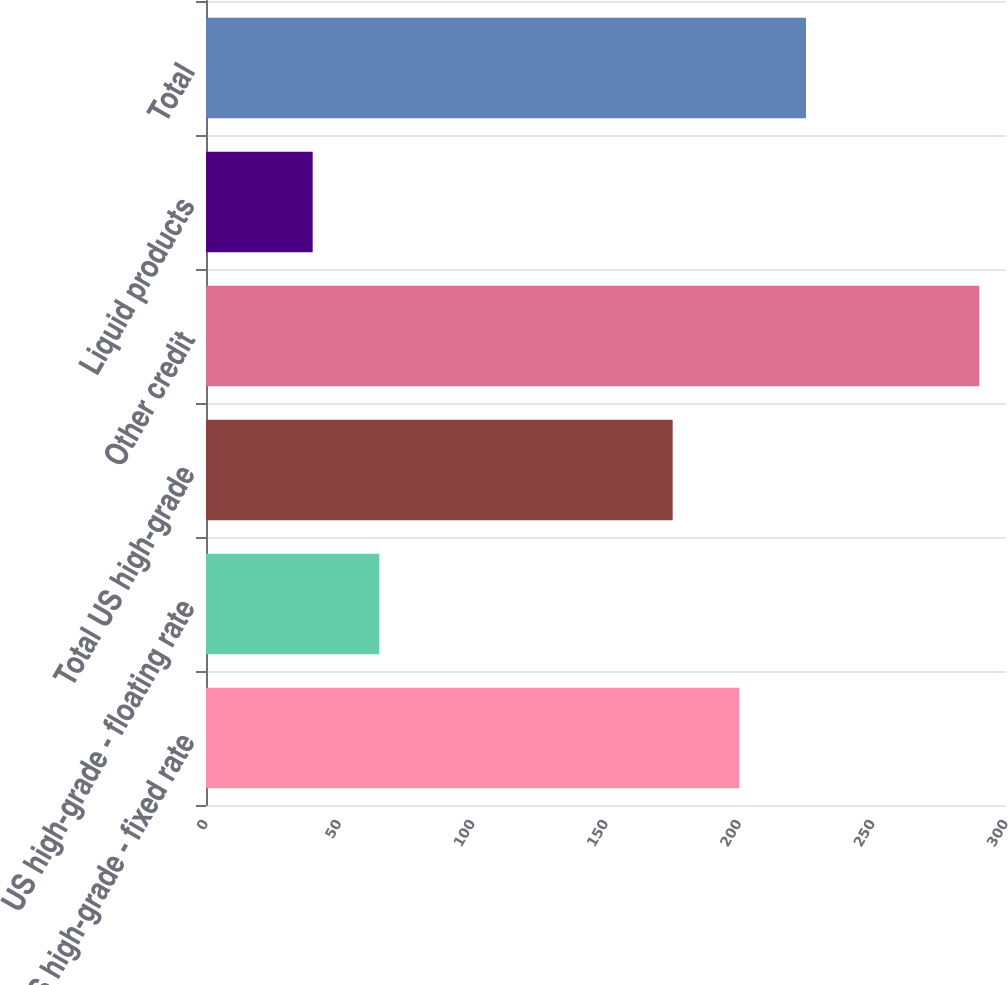Convert chart to OTSL. <chart><loc_0><loc_0><loc_500><loc_500><bar_chart><fcel>US high-grade - fixed rate<fcel>US high-grade - floating rate<fcel>Total US high-grade<fcel>Other credit<fcel>Liquid products<fcel>Total<nl><fcel>200<fcel>65<fcel>175<fcel>290<fcel>40<fcel>225<nl></chart> 